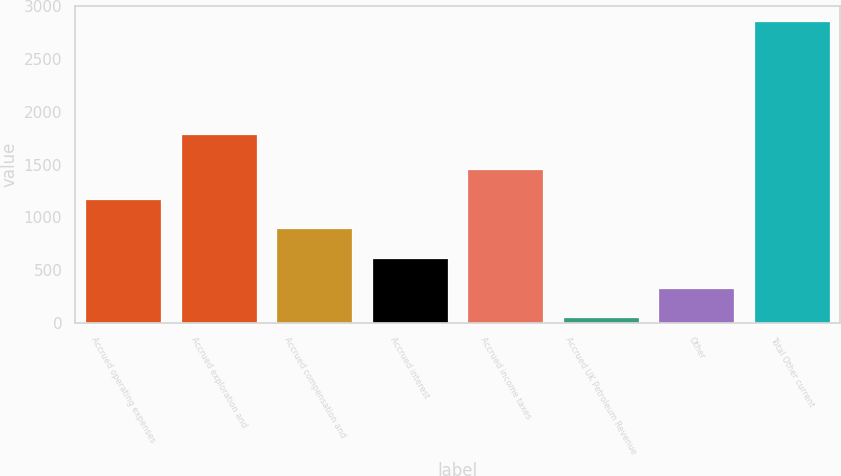<chart> <loc_0><loc_0><loc_500><loc_500><bar_chart><fcel>Accrued operating expenses<fcel>Accrued exploration and<fcel>Accrued compensation and<fcel>Accrued interest<fcel>Accrued income taxes<fcel>Accrued UK Petroleum Revenue<fcel>Other<fcel>Total Other current<nl><fcel>1175.8<fcel>1792<fcel>895.1<fcel>614.4<fcel>1456.5<fcel>53<fcel>333.7<fcel>2860<nl></chart> 